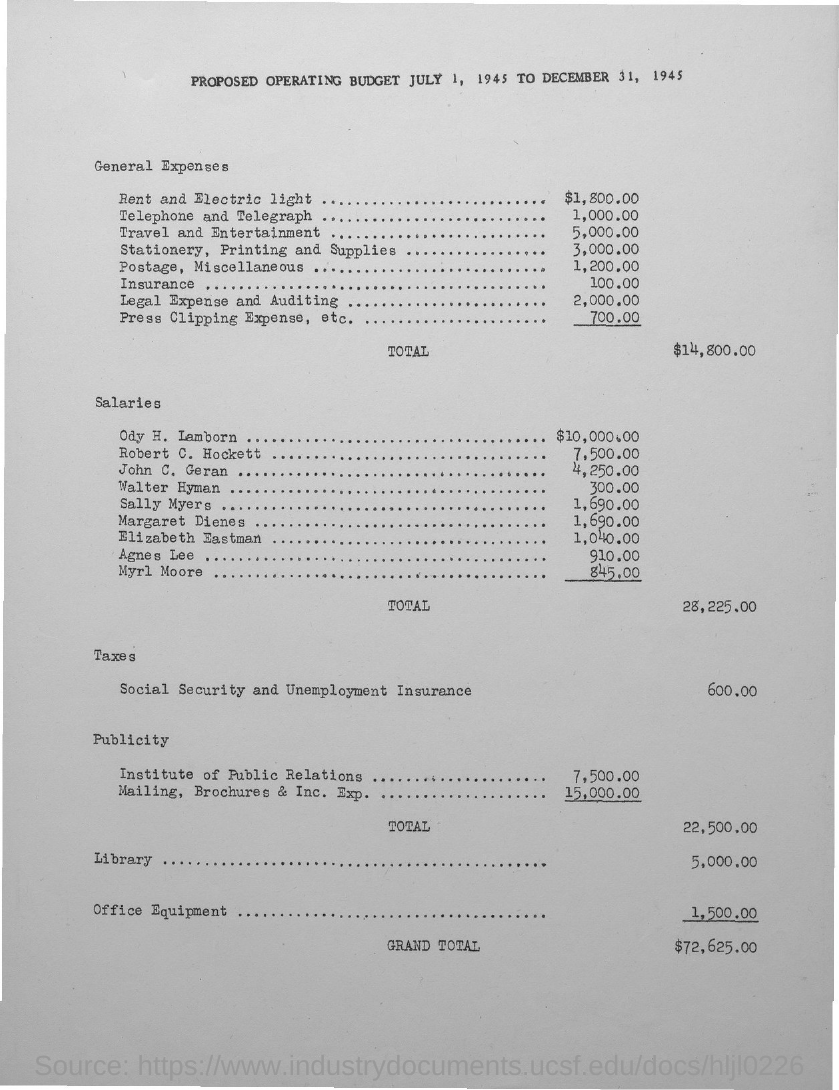Give some essential details in this illustration. The total general expenses are $14,800.00. The total salary is 28,225.00. 